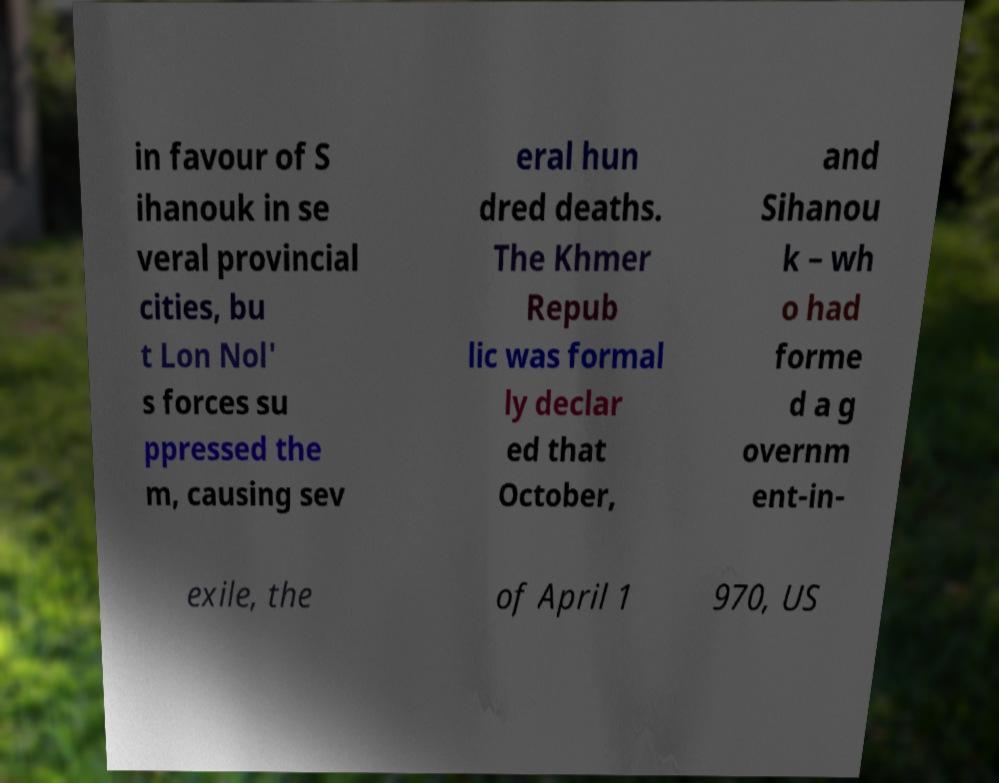Can you read and provide the text displayed in the image?This photo seems to have some interesting text. Can you extract and type it out for me? in favour of S ihanouk in se veral provincial cities, bu t Lon Nol' s forces su ppressed the m, causing sev eral hun dred deaths. The Khmer Repub lic was formal ly declar ed that October, and Sihanou k – wh o had forme d a g overnm ent-in- exile, the of April 1 970, US 